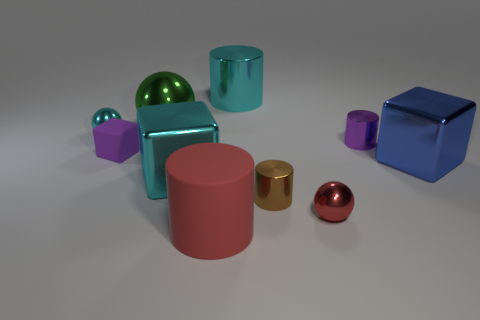Subtract 1 cylinders. How many cylinders are left? 3 Subtract all balls. How many objects are left? 7 Add 7 small purple shiny objects. How many small purple shiny objects are left? 8 Add 8 brown matte blocks. How many brown matte blocks exist? 8 Subtract 0 gray blocks. How many objects are left? 10 Subtract all red objects. Subtract all large rubber cylinders. How many objects are left? 7 